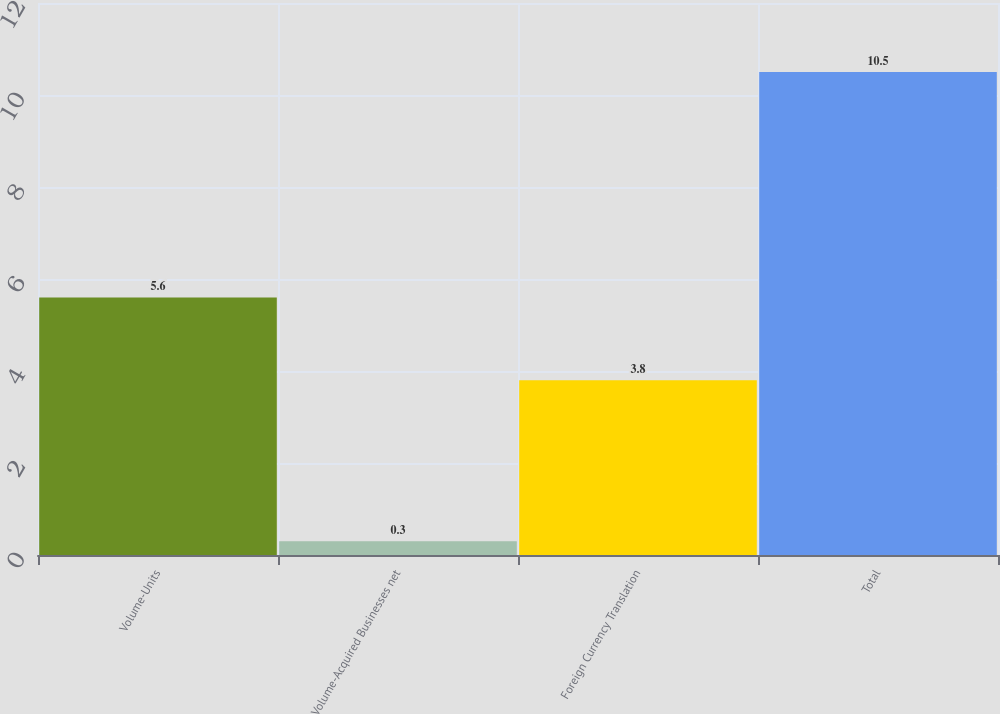<chart> <loc_0><loc_0><loc_500><loc_500><bar_chart><fcel>Volume-Units<fcel>Volume-Acquired Businesses net<fcel>Foreign Currency Translation<fcel>Total<nl><fcel>5.6<fcel>0.3<fcel>3.8<fcel>10.5<nl></chart> 